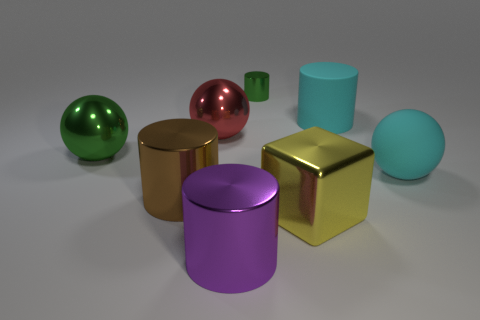Subtract all big cylinders. How many cylinders are left? 1 Subtract 2 cylinders. How many cylinders are left? 2 Subtract all red cylinders. Subtract all blue blocks. How many cylinders are left? 4 Add 2 large blue matte spheres. How many objects exist? 10 Subtract all brown shiny things. Subtract all tiny brown rubber objects. How many objects are left? 7 Add 3 cyan spheres. How many cyan spheres are left? 4 Add 4 big purple metal cubes. How many big purple metal cubes exist? 4 Subtract 0 gray cylinders. How many objects are left? 8 Subtract all spheres. How many objects are left? 5 